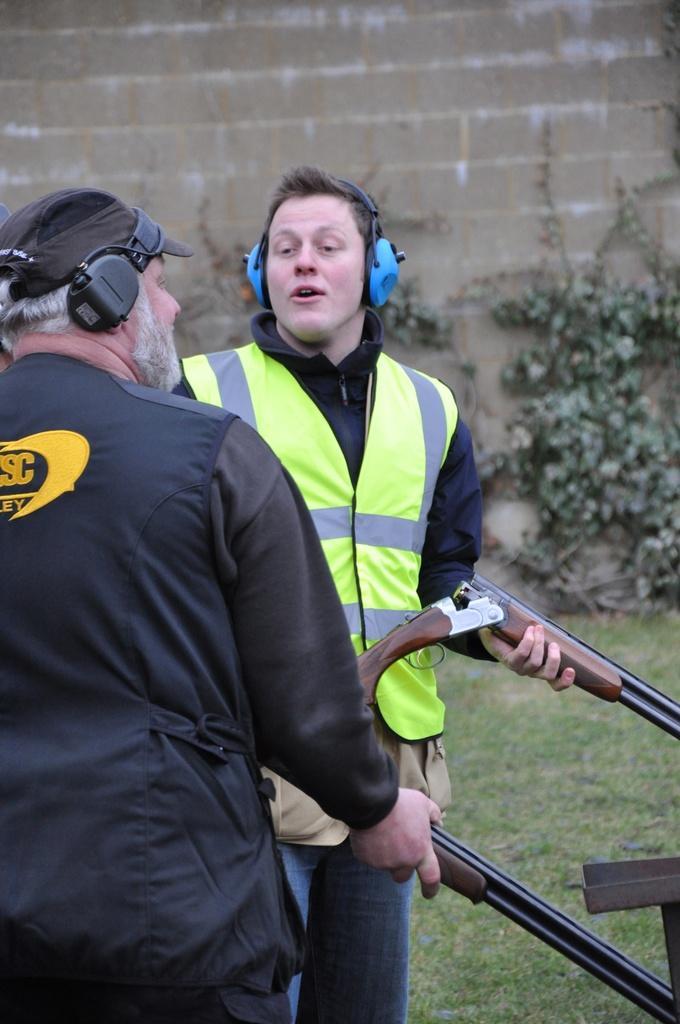In one or two sentences, can you explain what this image depicts? In this image, in the middle there is a man, he is holding a gun. On the left there is a man, he is holding a gun. In the background there are plants, grass, wall. 